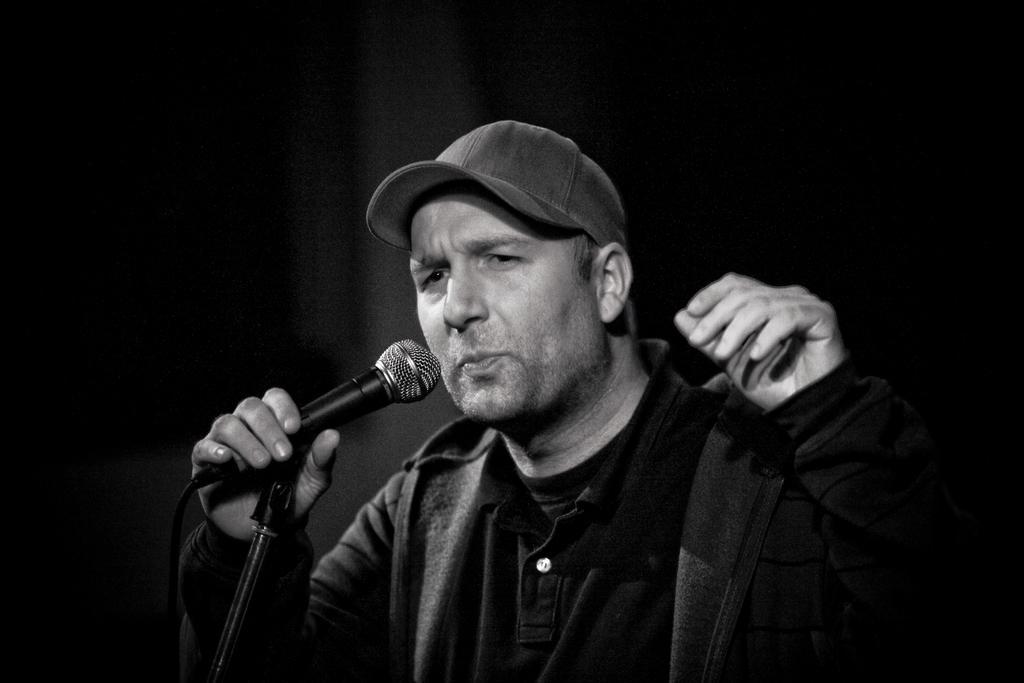Please provide a concise description of this image. In the picture there is a man. He is wearing a cap, a T-shirt and hoodie over it. In front of him there is a microphone and microphone stand. He is holding the microphone. 